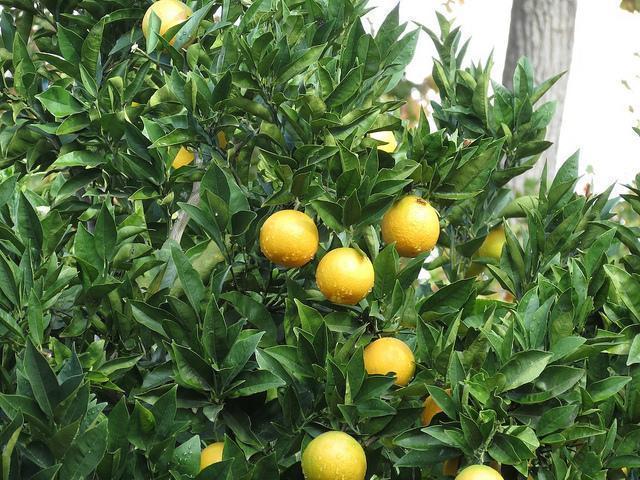What type of fruit is most likely on the tree?
Make your selection from the four choices given to correctly answer the question.
Options: Lime, dragonfruit, apple, lemon. Lemon. 